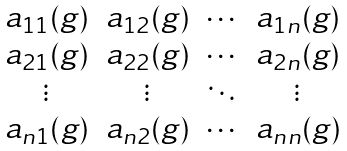<formula> <loc_0><loc_0><loc_500><loc_500>\begin{matrix} a _ { 1 1 } ( g ) & a _ { 1 2 } ( g ) & \cdots & a _ { 1 n } ( g ) \\ a _ { 2 1 } ( g ) & a _ { 2 2 } ( g ) & \cdots & a _ { 2 n } ( g ) \\ \vdots & \vdots & \ddots & \vdots \\ a _ { n 1 } ( g ) & a _ { n 2 } ( g ) & \cdots & a _ { n n } ( g ) \end{matrix}</formula> 